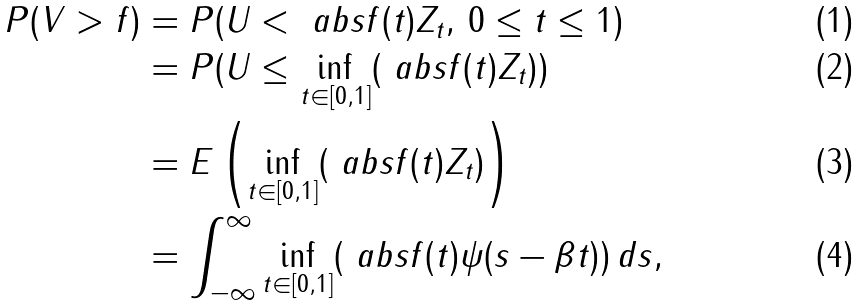Convert formula to latex. <formula><loc_0><loc_0><loc_500><loc_500>P ( V > f ) & = P ( U < \ a b s { f ( t ) } Z _ { t } , \, 0 \leq t \leq 1 ) \\ & = P ( U \leq \inf _ { t \in [ 0 , 1 ] } ( \ a b s { f ( t ) } Z _ { t } ) ) \\ & = E \left ( \inf _ { t \in [ 0 , 1 ] } ( \ a b s { f ( t ) } Z _ { t } ) \right ) \\ & = \int _ { - \infty } ^ { \infty } \inf _ { t \in [ 0 , 1 ] } ( \ a b s { f ( t ) } \psi ( s - \beta t ) ) \, d s ,</formula> 